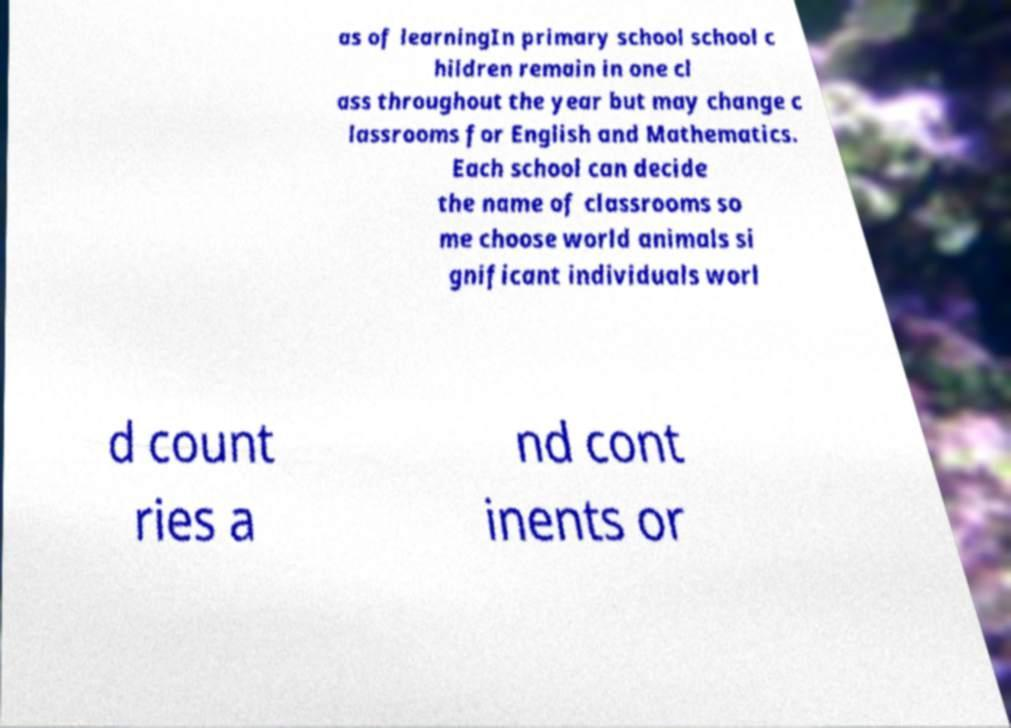For documentation purposes, I need the text within this image transcribed. Could you provide that? as of learningIn primary school school c hildren remain in one cl ass throughout the year but may change c lassrooms for English and Mathematics. Each school can decide the name of classrooms so me choose world animals si gnificant individuals worl d count ries a nd cont inents or 